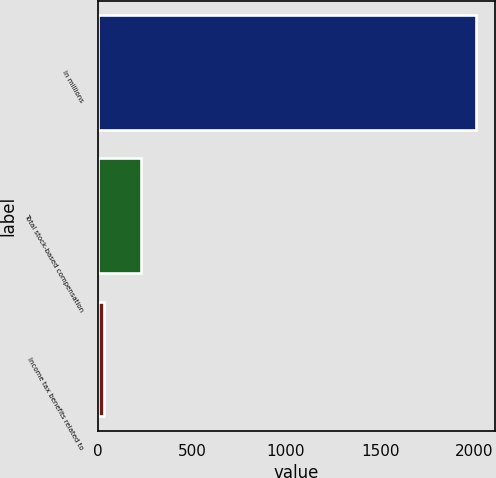Convert chart to OTSL. <chart><loc_0><loc_0><loc_500><loc_500><bar_chart><fcel>In millions<fcel>Total stock-based compensation<fcel>Income tax benefits related to<nl><fcel>2011<fcel>231.7<fcel>34<nl></chart> 